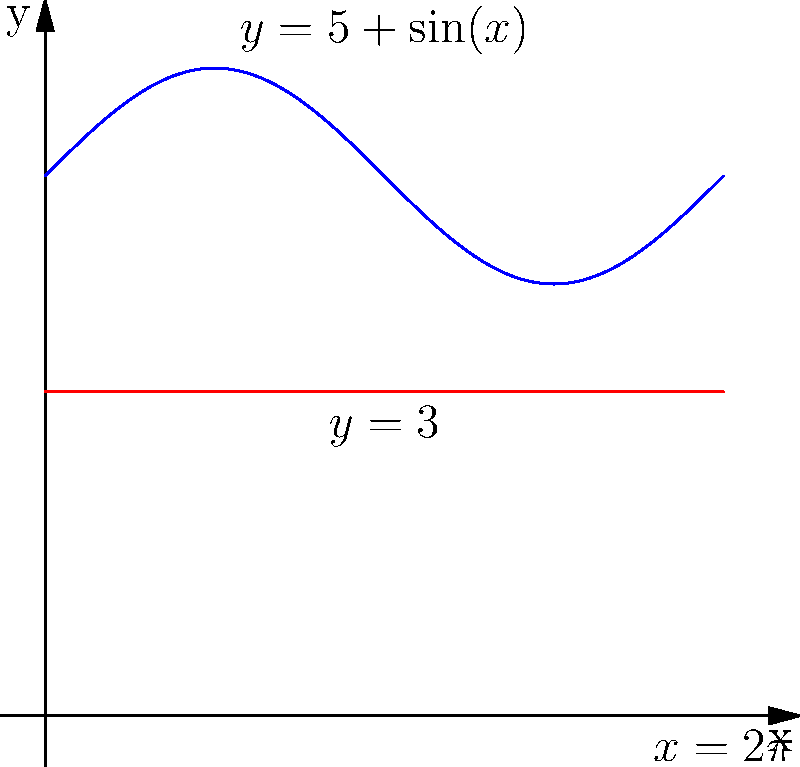A new music venue in Vancouver reminds you of your favorite indie concert space back in Toronto. The venue's unique shape can be modeled by rotating the region bounded by $y=5+\sin(x)$, $y=3$, and $x=2\pi$ about the x-axis. Calculate the volume of this solid of revolution using the washer method. To solve this problem, we'll use the washer method for calculating the volume of a solid of revolution:

1) The washer method formula is:
   $$V = \pi \int_a^b [R(x)^2 - r(x)^2] dx$$
   where $R(x)$ is the outer radius function and $r(x)$ is the inner radius function.

2) In this case:
   $R(x) = 5+\sin(x)$
   $r(x) = 3$
   $a = 0$, $b = 2\pi$

3) Substituting into the formula:
   $$V = \pi \int_0^{2\pi} [(5+\sin(x))^2 - 3^2] dx$$

4) Expanding the squared term:
   $$V = \pi \int_0^{2\pi} [25 + 10\sin(x) + \sin^2(x) - 9] dx$$

5) Simplifying:
   $$V = \pi \int_0^{2\pi} [16 + 10\sin(x) + \sin^2(x)] dx$$

6) Integrating term by term:
   $$V = \pi [16x - 10\cos(x) + \frac{x}{2} - \frac{\sin(2x)}{4}]_0^{2\pi}$$

7) Evaluating the integral:
   $$V = \pi [32\pi - 10(\cos(2\pi) - \cos(0)) + \pi - 0]$$

8) Simplifying:
   $$V = \pi [32\pi + \pi] = 33\pi^2$$

Therefore, the volume of the solid of revolution is $33\pi^2$ cubic units.
Answer: $33\pi^2$ cubic units 